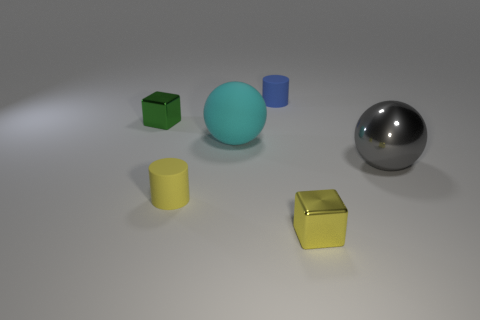Are there fewer yellow rubber objects right of the gray metal ball than yellow blocks that are behind the tiny blue cylinder?
Give a very brief answer. No. There is a shiny thing that is both right of the blue thing and on the left side of the shiny sphere; how big is it?
Your answer should be compact. Small. There is a metallic sphere behind the block in front of the large rubber sphere; is there a blue matte object on the right side of it?
Make the answer very short. No. Are there any tiny green cubes?
Provide a succinct answer. Yes. Are there more tiny green blocks in front of the big matte sphere than tiny green things to the right of the yellow cylinder?
Your answer should be very brief. No. There is a cyan ball that is made of the same material as the small blue thing; what is its size?
Give a very brief answer. Large. There is a yellow metallic block in front of the thing that is left of the rubber cylinder in front of the large cyan rubber thing; what size is it?
Offer a very short reply. Small. There is a small shiny thing in front of the large cyan matte thing; what is its color?
Offer a very short reply. Yellow. Are there more shiny objects that are right of the tiny yellow cylinder than yellow cubes?
Your answer should be very brief. Yes. There is a matte thing that is in front of the gray object; is it the same shape as the cyan rubber thing?
Your answer should be very brief. No. 